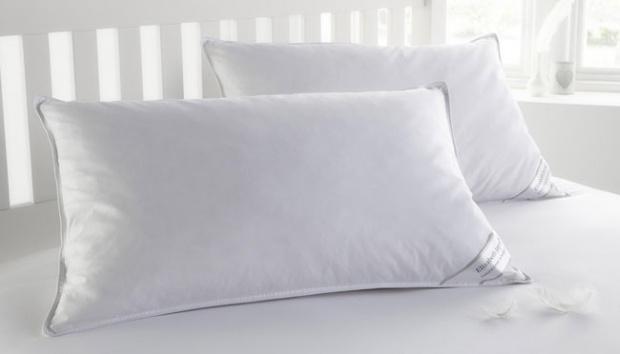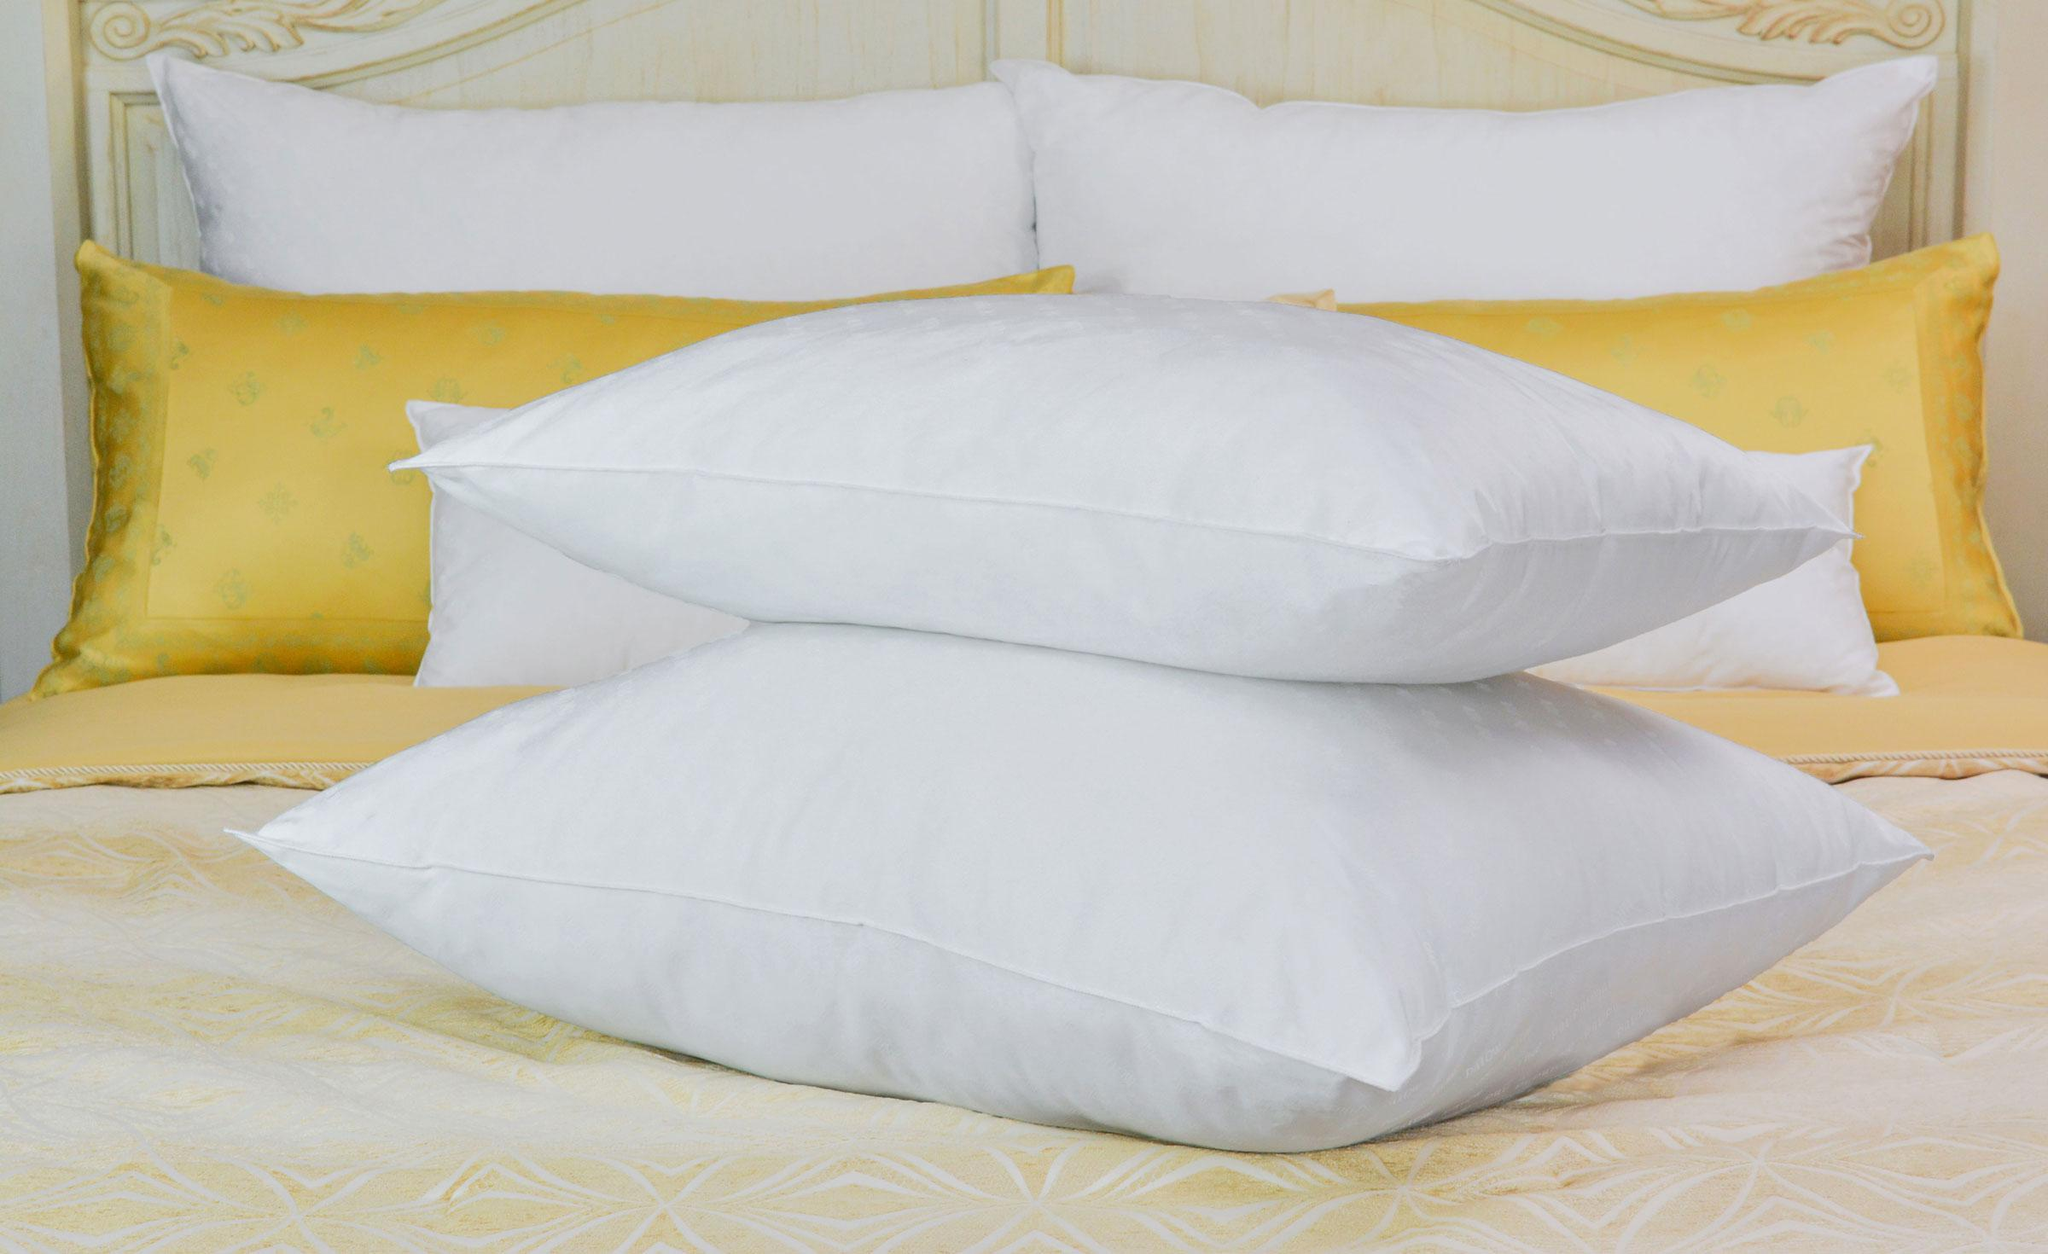The first image is the image on the left, the second image is the image on the right. For the images shown, is this caption "There are more pillows in the image on the right." true? Answer yes or no. Yes. The first image is the image on the left, the second image is the image on the right. For the images displayed, is the sentence "One image features a sculpted pillow style with a concave shape, and the other image features a pillow style with pointed corners." factually correct? Answer yes or no. No. 